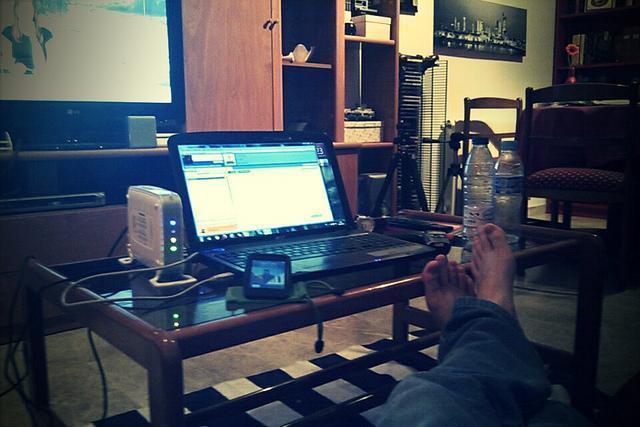How many bottles of water are on the table?
Give a very brief answer. 2. How many chairs are visible?
Give a very brief answer. 2. How many bottles are there?
Give a very brief answer. 2. How many pieces is the sandwich cut in to?
Give a very brief answer. 0. 